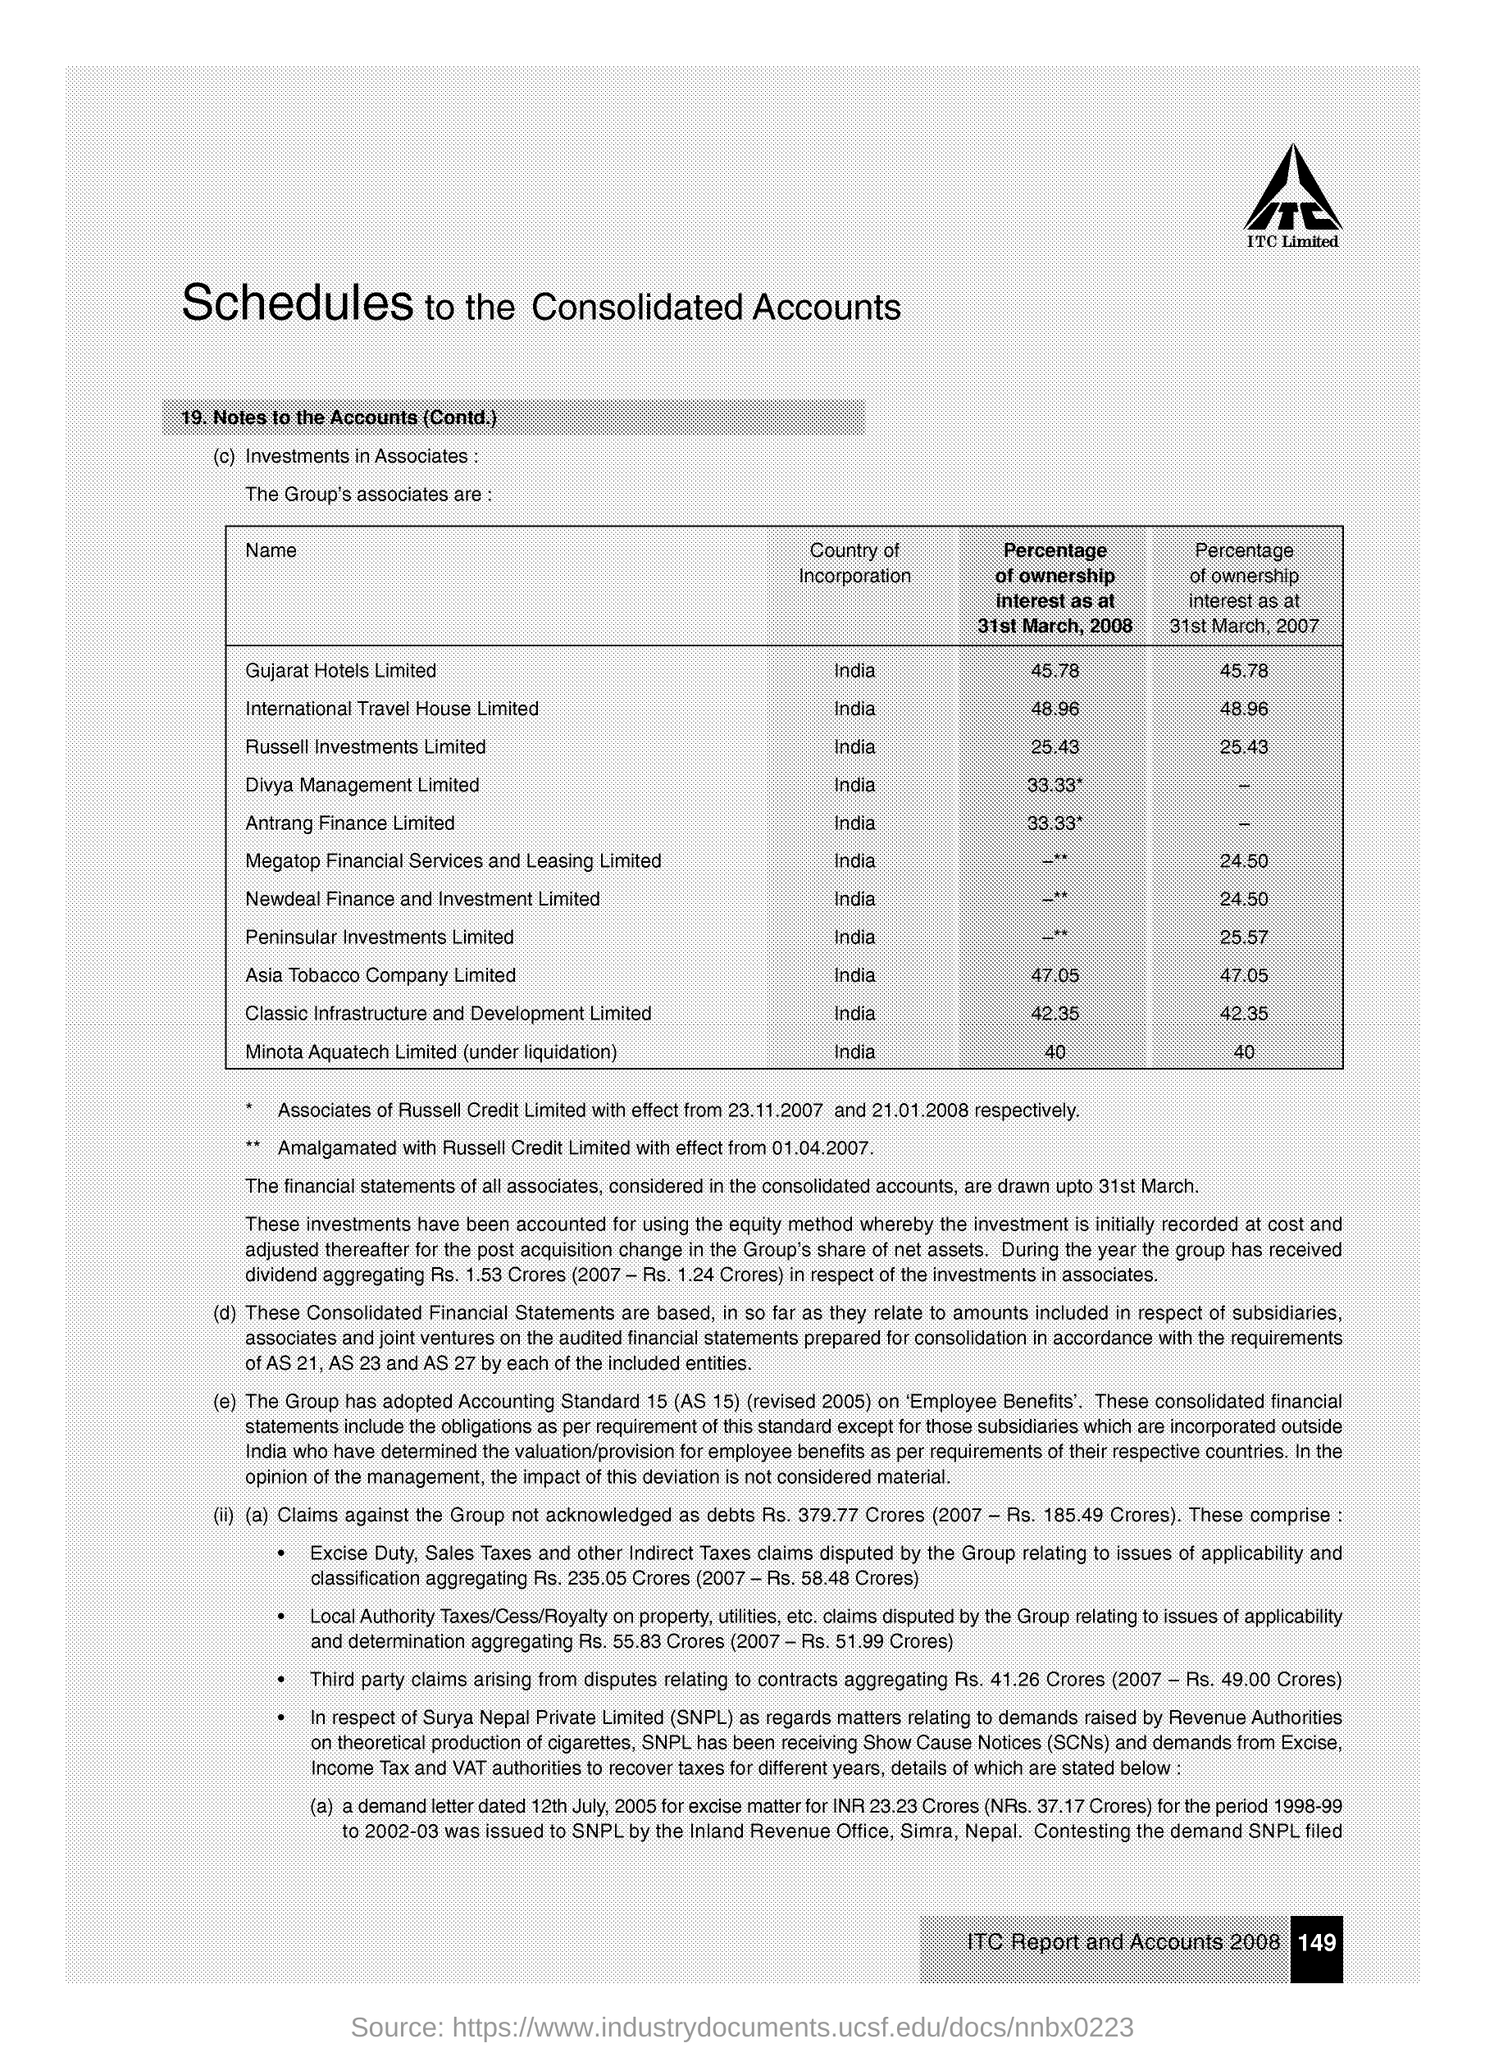Highlight a few significant elements in this photo. The page number mentioned in this document is 149. Antrang Finance Limited is incorporated in India. As of March 31st, 2007, Peninsular Investments Limited's ownership interest was 25.57%. As at 31st March, 2008, Asia Tobacco Company Limited's ownership interest was 47.05%. As of March 31, 2008, Gujarat Hotels Limited owned 45.78% of the company's assets. 